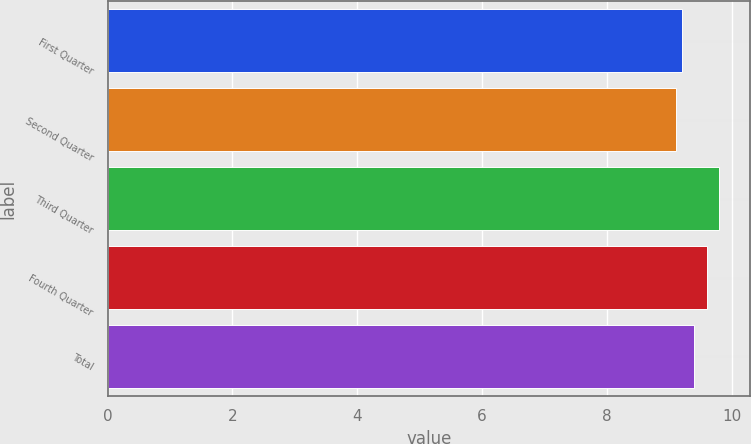Convert chart. <chart><loc_0><loc_0><loc_500><loc_500><bar_chart><fcel>First Quarter<fcel>Second Quarter<fcel>Third Quarter<fcel>Fourth Quarter<fcel>Total<nl><fcel>9.2<fcel>9.1<fcel>9.8<fcel>9.6<fcel>9.4<nl></chart> 